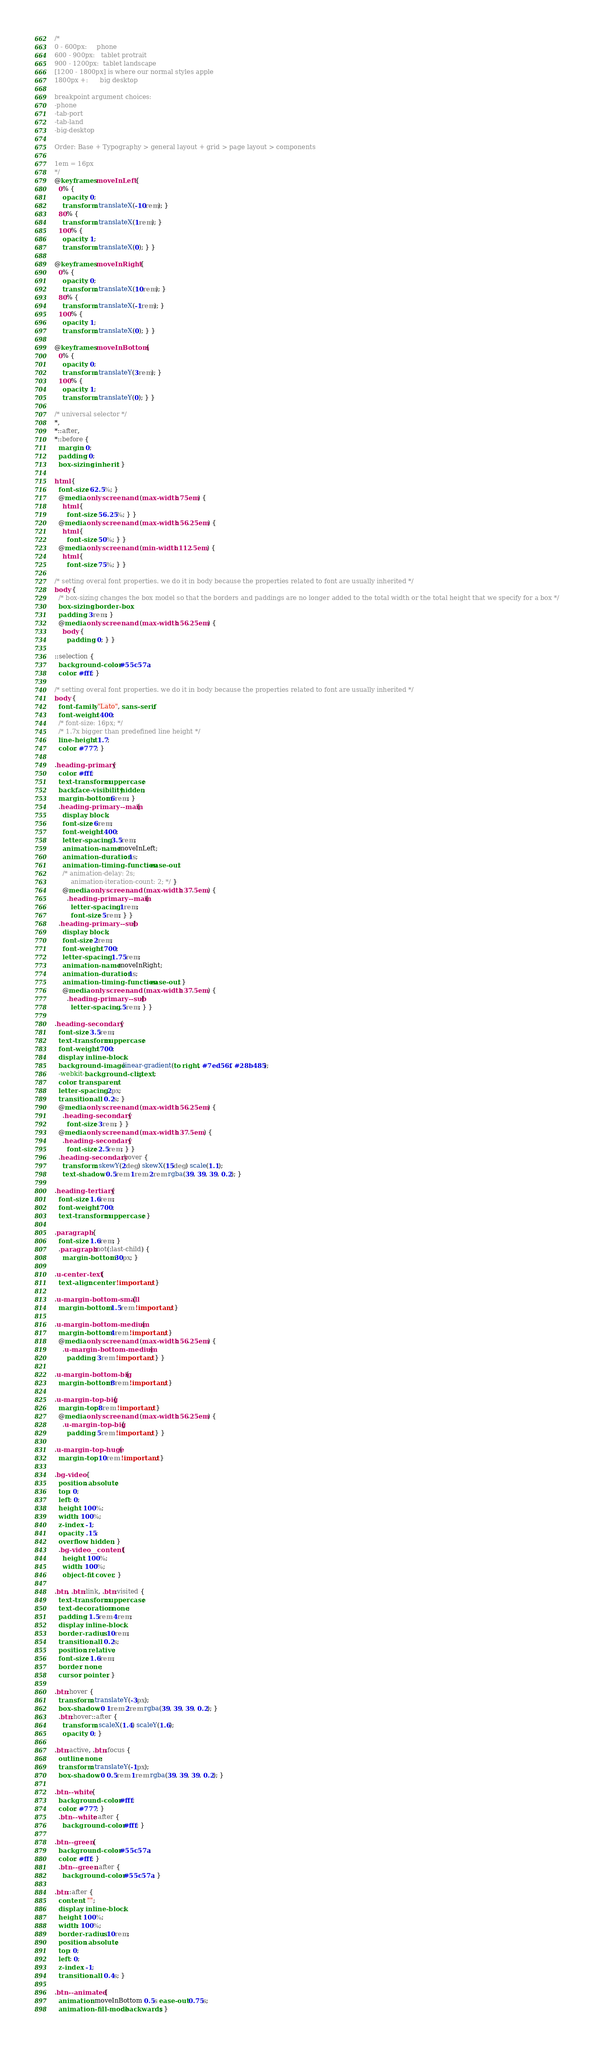Convert code to text. <code><loc_0><loc_0><loc_500><loc_500><_CSS_>/*
0 - 600px:     phone
600 - 900px:   tablet protrait
900 - 1200px:  tablet landscape
[1200 - 1800px] is where our normal styles apple
1800px +:      big desktop 

breakpoint argument choices:
-phone
-tab-port
-tab-land
-big-desktop

Order: Base + Typography > general layout + grid > page layout > components

1em = 16px
*/
@keyframes moveInLeft {
  0% {
    opacity: 0;
    transform: translateX(-10rem); }
  80% {
    transform: translateX(1rem); }
  100% {
    opacity: 1;
    transform: translateX(0); } }

@keyframes moveInRight {
  0% {
    opacity: 0;
    transform: translateX(10rem); }
  80% {
    transform: translateX(-1rem); }
  100% {
    opacity: 1;
    transform: translateX(0); } }

@keyframes moveInBottom {
  0% {
    opacity: 0;
    transform: translateY(3rem); }
  100% {
    opacity: 1;
    transform: translateY(0); } }

/* universal selector */
*,
*::after,
*::before {
  margin: 0;
  padding: 0;
  box-sizing: inherit; }

html {
  font-size: 62.5%; }
  @media only screen and (max-width: 75em) {
    html {
      font-size: 56.25%; } }
  @media only screen and (max-width: 56.25em) {
    html {
      font-size: 50%; } }
  @media only screen and (min-width: 112.5em) {
    html {
      font-size: 75%; } }

/* setting overal font properties. we do it in body because the properties related to font are usually inherited */
body {
  /* box-sizing changes the box model so that the borders and paddings are no longer added to the total width or the total height that we specify for a box */
  box-sizing: border-box;
  padding: 3rem; }
  @media only screen and (max-width: 56.25em) {
    body {
      padding: 0; } }

::selection {
  background-color: #55c57a;
  color: #fff; }

/* setting overal font properties. we do it in body because the properties related to font are usually inherited */
body {
  font-family: "Lato", sans-serif;
  font-weight: 400;
  /* font-size: 16px; */
  /* 1.7x bigger than predefined line height */
  line-height: 1.7;
  color: #777; }

.heading-primary {
  color: #fff;
  text-transform: uppercase;
  backface-visibility: hidden;
  margin-bottom: 6rem; }
  .heading-primary--main {
    display: block;
    font-size: 6rem;
    font-weight: 400;
    letter-spacing: 3.5rem;
    animation-name: moveInLeft;
    animation-duration: 1s;
    animation-timing-function: ease-out;
    /* animation-delay: 2s;
        animation-iteration-count: 2; */ }
    @media only screen and (max-width: 37.5em) {
      .heading-primary--main {
        letter-spacing: 1rem;
        font-size: 5rem; } }
  .heading-primary--sub {
    display: block;
    font-size: 2rem;
    font-weight: 700;
    letter-spacing: 1.75rem;
    animation-name: moveInRight;
    animation-duration: 1s;
    animation-timing-function: ease-out; }
    @media only screen and (max-width: 37.5em) {
      .heading-primary--sub {
        letter-spacing: .5rem; } }

.heading-secondary {
  font-size: 3.5rem;
  text-transform: uppercase;
  font-weight: 700;
  display: inline-block;
  background-image: linear-gradient(to right, #7ed56f, #28b485);
  -webkit-background-clip: text;
  color: transparent;
  letter-spacing: 2px;
  transition: all 0.2s; }
  @media only screen and (max-width: 56.25em) {
    .heading-secondary {
      font-size: 3rem; } }
  @media only screen and (max-width: 37.5em) {
    .heading-secondary {
      font-size: 2.5rem; } }
  .heading-secondary:hover {
    transform: skewY(2deg) skewX(15deg) scale(1.1);
    text-shadow: 0.5rem 1rem 2rem rgba(39, 39, 39, 0.2); }

.heading-tertiary {
  font-size: 1.6rem;
  font-weight: 700;
  text-transform: uppercase; }

.paragraph {
  font-size: 1.6rem; }
  .paragraph:not(:last-child) {
    margin-bottom: 30px; }

.u-center-text {
  text-align: center !important; }

.u-margin-bottom-small {
  margin-bottom: 1.5rem !important; }

.u-margin-bottom-medium {
  margin-bottom: 4rem !important; }
  @media only screen and (max-width: 56.25em) {
    .u-margin-bottom-medium {
      padding: 3rem !important; } }

.u-margin-bottom-big {
  margin-bottom: 8rem !important; }

.u-margin-top-big {
  margin-top: 8rem !important; }
  @media only screen and (max-width: 56.25em) {
    .u-margin-top-big {
      padding: 5rem !important; } }

.u-margin-top-huge {
  margin-top: 10rem !important; }

.bg-video {
  position: absolute;
  top: 0;
  left: 0;
  height: 100%;
  width: 100%;
  z-index: -1;
  opacity: .15;
  overflow: hidden; }
  .bg-video__content {
    height: 100%;
    width: 100%;
    object-fit: cover; }

.btn, .btn:link, .btn:visited {
  text-transform: uppercase;
  text-decoration: none;
  padding: 1.5rem 4rem;
  display: inline-block;
  border-radius: 10rem;
  transition: all 0.2s;
  position: relative;
  font-size: 1.6rem;
  border: none;
  cursor: pointer; }

.btn:hover {
  transform: translateY(-3px);
  box-shadow: 0 1rem 2rem rgba(39, 39, 39, 0.2); }
  .btn:hover::after {
    transform: scaleX(1.4) scaleY(1.6);
    opacity: 0; }

.btn:active, .btn:focus {
  outline: none;
  transform: translateY(-1px);
  box-shadow: 0 0.5rem 1rem rgba(39, 39, 39, 0.2); }

.btn--white {
  background-color: #fff;
  color: #777; }
  .btn--white::after {
    background-color: #fff; }

.btn--green {
  background-color: #55c57a;
  color: #fff; }
  .btn--green::after {
    background-color: #55c57a; }

.btn::after {
  content: "";
  display: inline-block;
  height: 100%;
  width: 100%;
  border-radius: 10rem;
  position: absolute;
  top: 0;
  left: 0;
  z-index: -1;
  transition: all 0.4s; }

.btn--animated {
  animation: moveInBottom 0.5s ease-out 0.75s;
  animation-fill-mode: backwards; }
</code> 